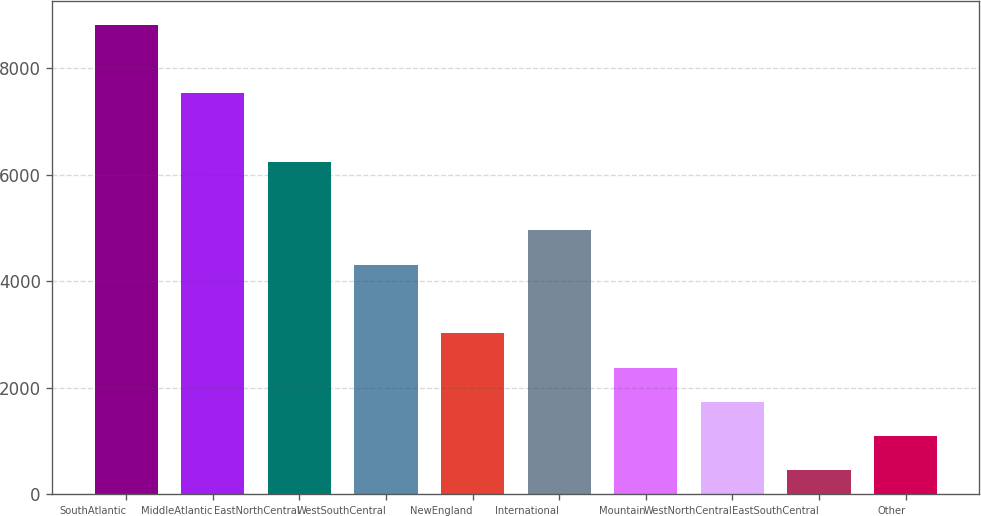<chart> <loc_0><loc_0><loc_500><loc_500><bar_chart><fcel>SouthAtlantic<fcel>MiddleAtlantic<fcel>EastNorthCentral<fcel>WestSouthCentral<fcel>NewEngland<fcel>International<fcel>Mountain<fcel>WestNorthCentral<fcel>EastSouthCentral<fcel>Other<nl><fcel>8809.7<fcel>7523.9<fcel>6238.1<fcel>4309.4<fcel>3023.6<fcel>4952.3<fcel>2380.7<fcel>1737.8<fcel>452<fcel>1094.9<nl></chart> 